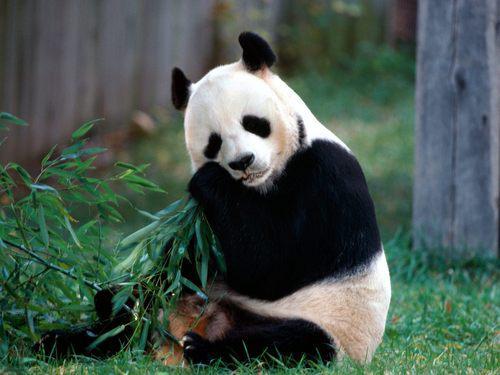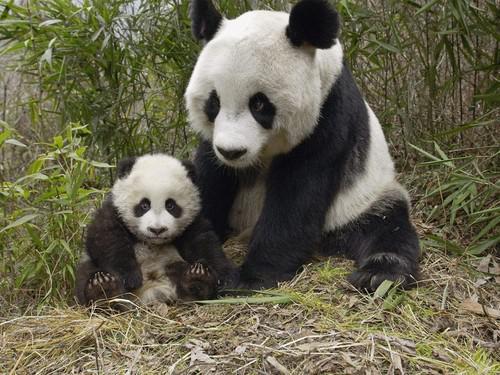The first image is the image on the left, the second image is the image on the right. For the images displayed, is the sentence "There are no more than 3 pandas in the image pair" factually correct? Answer yes or no. Yes. The first image is the image on the left, the second image is the image on the right. For the images displayed, is the sentence "One image features a baby panda next to an adult panda" factually correct? Answer yes or no. Yes. 